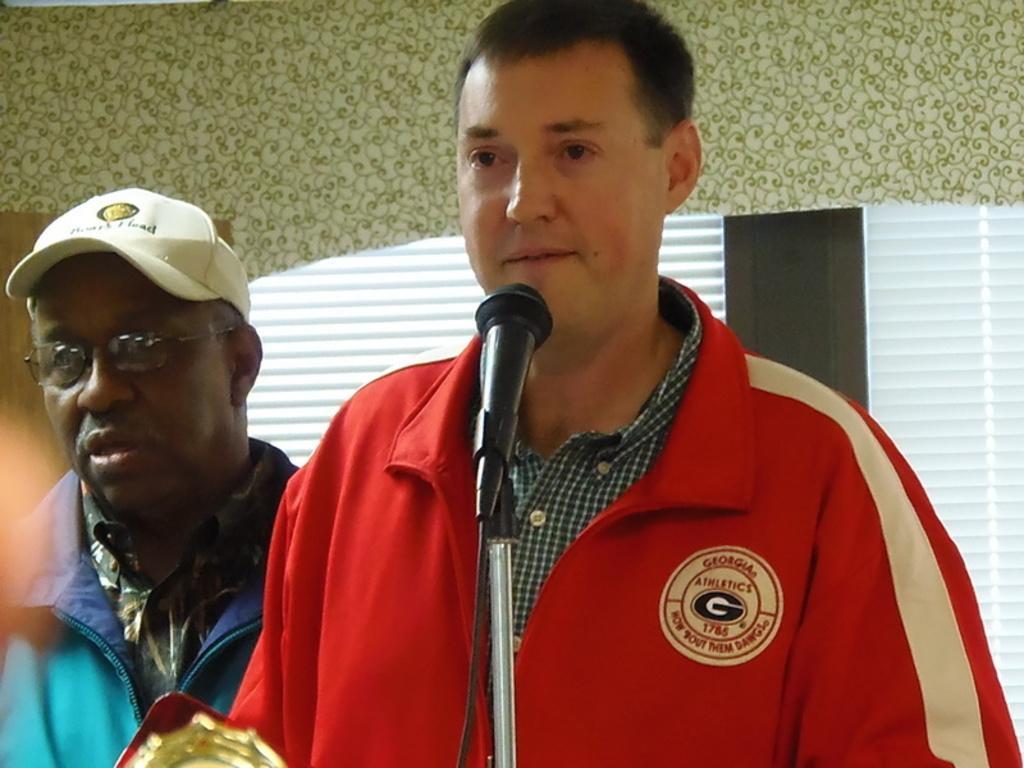Could you give a brief overview of what you see in this image? In the center of the image there is a person standing at the mic. On the left side of the image there is a person. In the background there is a wall and window. 